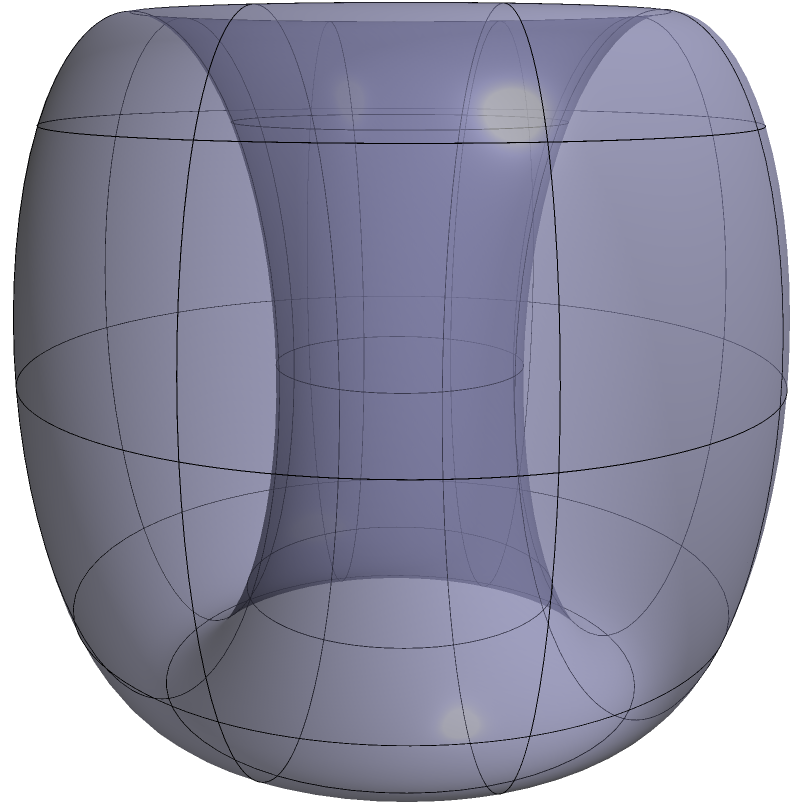Consider a Klein bottle with major radius $R = 2$ units and minor radius $r = 1$ unit. Calculate the surface area of this Klein bottle using the formula:

$$ A = 4\pi^2 r R $$

where $A$ is the surface area, $r$ is the minor radius, and $R$ is the major radius. How does this result relate to the surface area of a torus with the same dimensions? To solve this problem, we'll follow these steps:

1) First, let's recall the formula for the surface area of a Klein bottle:
   $$ A = 4\pi^2 r R $$

2) We're given:
   $R = 2$ units (major radius)
   $r = 1$ unit (minor radius)

3) Let's substitute these values into our formula:
   $$ A = 4\pi^2 \cdot 1 \cdot 2 $$

4) Simplify:
   $$ A = 8\pi^2 $$

5) This gives us the surface area in square units.

6) To relate this to a torus, recall that the surface area of a torus is given by:
   $$ A_{torus} = 4\pi^2 r R $$

7) Interestingly, this is the same formula as for the Klein bottle. This means that a Klein bottle and a torus with the same major and minor radii will have the same surface area, despite their different topological properties.

8) This similarity in surface area formulas highlights a deep connection between these two surfaces in differential geometry, despite their distinct global structures. The Klein bottle is non-orientable and cannot be embedded in 3D space without self-intersection, while the torus is orientable and can be embedded in 3D space.
Answer: $8\pi^2$ square units 